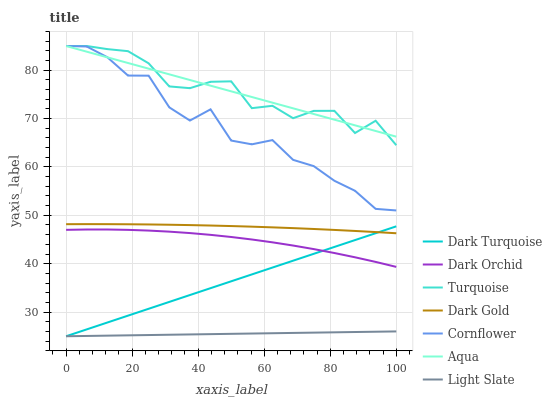Does Light Slate have the minimum area under the curve?
Answer yes or no. Yes. Does Turquoise have the maximum area under the curve?
Answer yes or no. Yes. Does Dark Gold have the minimum area under the curve?
Answer yes or no. No. Does Dark Gold have the maximum area under the curve?
Answer yes or no. No. Is Light Slate the smoothest?
Answer yes or no. Yes. Is Cornflower the roughest?
Answer yes or no. Yes. Is Turquoise the smoothest?
Answer yes or no. No. Is Turquoise the roughest?
Answer yes or no. No. Does Turquoise have the lowest value?
Answer yes or no. No. Does Dark Gold have the highest value?
Answer yes or no. No. Is Light Slate less than Cornflower?
Answer yes or no. Yes. Is Cornflower greater than Dark Turquoise?
Answer yes or no. Yes. Does Light Slate intersect Cornflower?
Answer yes or no. No. 